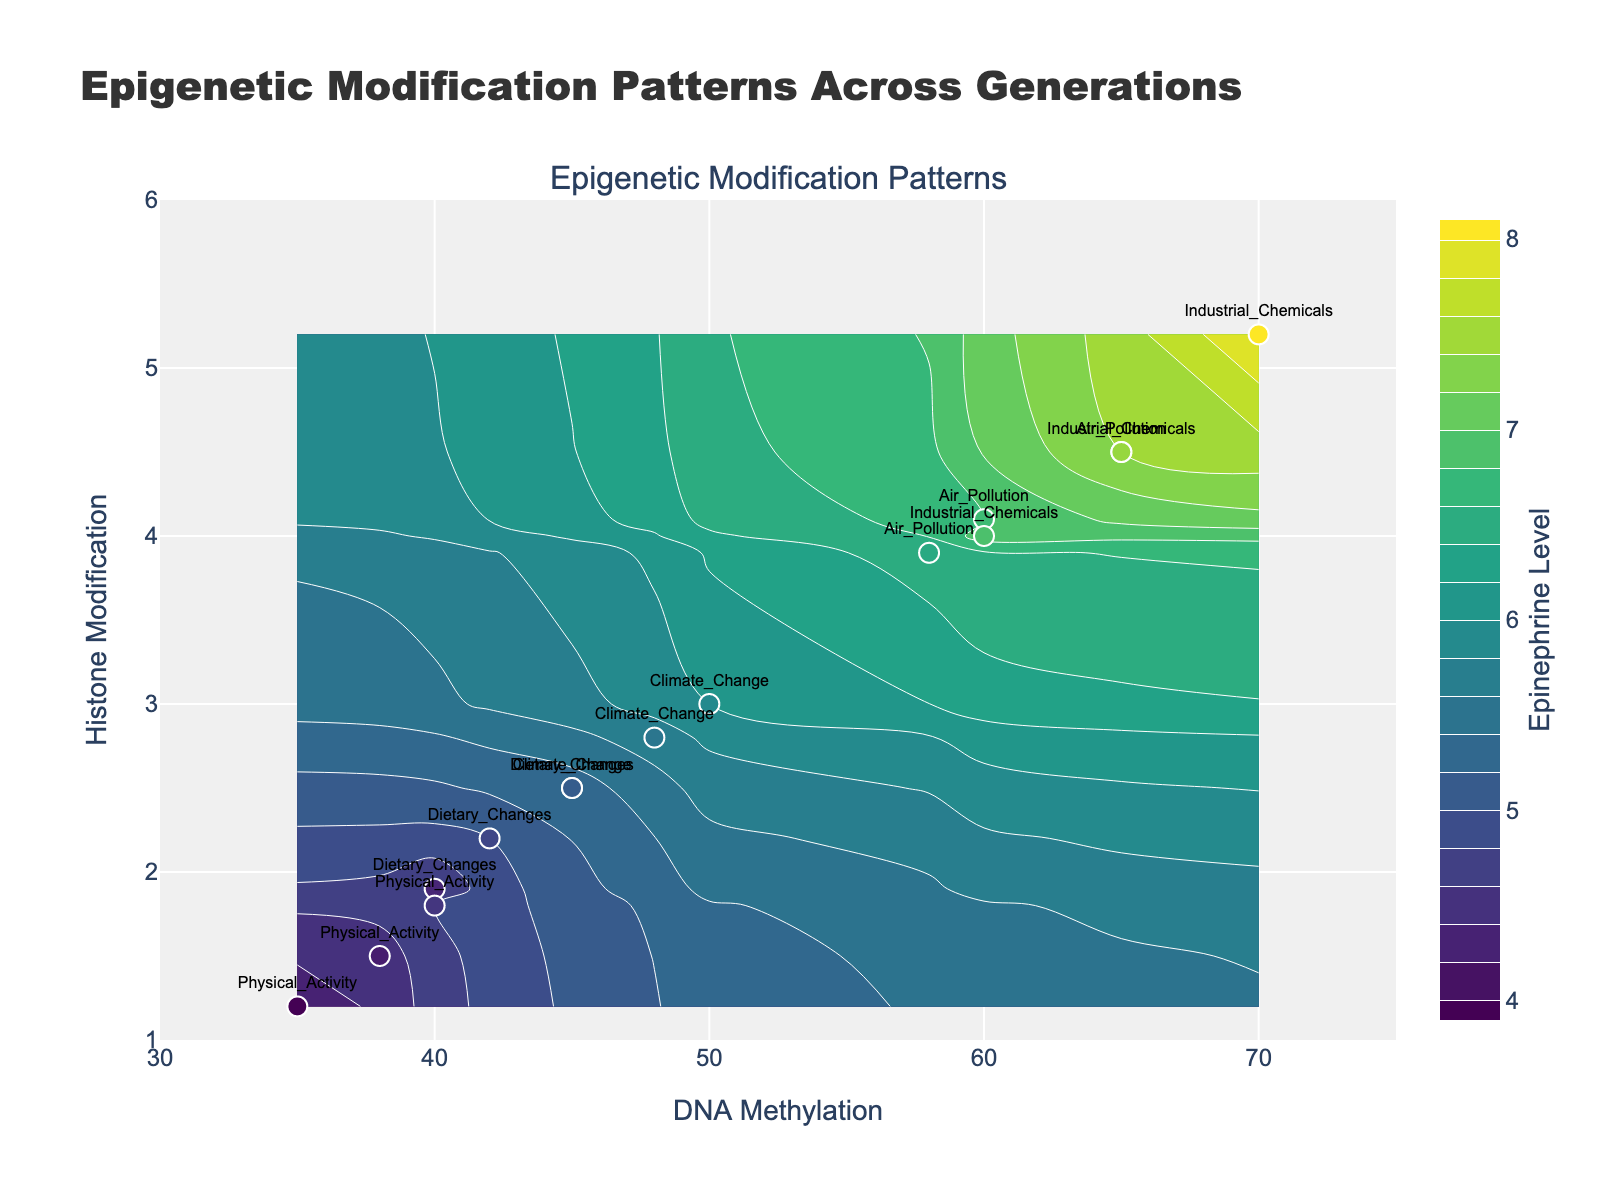What is the title of the figure? The title of the figure is located at the top and reads "Epigenetic Modification Patterns Across Generations".
Answer: Epigenetic Modification Patterns Across Generations What are the ranges of the x-axis and y-axis? The x-axis (DNA Methylation) ranges from 30 to 75, and the y-axis (Histone Modification) ranges from 1 to 6, as indicated by the axis labels and tick marks.
Answer: DNA Methylation: 30-75, Histone Modification: 1-6 How does the epinephrine level vary across different environmental factors? To answer this, observe the color intensities and values on the contour plot associated with different environmental factors labeled on the scatter points. 'Industrial Chemicals' and 'Air Pollution' have higher epinephrine levels (warmer colors), while 'Physical Activity' and 'Dietary Changes' have lower levels (cooler colors).
Answer: Higher with 'Industrial Chemicals' and 'Air Pollution', lower with 'Physical Activity' and 'Dietary Changes' Which environmental factor in Generation 3 has the lowest epinephrine level? By examining the scatter points and their textual labels, we find that 'Physical Activity' in Generation 3 corresponds to the lowest epinephrine level, associated with the lowest color value on the color scale.
Answer: Physical Activity Between Air Pollution and Dietary Changes in Generation 1, which has a higher DNA Methylation level? Looking at the scatter data points for Generation 1, 'Air Pollution' corresponds to a DNA Methylation level of 65, while 'Dietary Changes' corresponds to a DNA Methylation level of 45, making 'Air Pollution' higher.
Answer: Air Pollution What is the range of histone modification levels for Climate Change across generations? The histone modification levels for 'Climate Change' across Generation 1, 2, and 3 are 3.0, 2.8, and 2.5, respectively.
Answer: 2.5 to 3.0 Which generation shows the highest variability in DNA Methylation levels among the different environmental factors? By comparing the DNA Methylation levels of the environmental factors within each generation, Generation 1 shows the highest variability, ranging from 40 (Physical Activity) to 70 (Industrial Chemicals).
Answer: Generation 1 What is the relationship between DNA Methylation and Histone Modification levels for Industrial Chemicals across generations? Observe the scatter points for 'Industrial Chemicals' across generations. DNA Methylation levels decrease from 70 to 60 while Histone Modification levels decrease from 5.2 to 4.0 over the generations. This indicates that as DNA Methylation decreases, Histone Modification also decreases.
Answer: Both decrease Which environmental factor is associated with the highest epinephrine level, and in which generation? The contour plot and scatter point labels show that 'Industrial Chemicals' in Generation 1 has the highest epinephrine level indicated by the highest color intensity.
Answer: Industrial Chemicals, Generation 1 What is the difference in DNA Methylation between Air Pollution in Generation 1 and Generation 3? The DNA Methylation levels for 'Air Pollution' in Generation 1 and Generation 3 are 65 and 58, respectively. The difference is 65 - 58 = 7.
Answer: 7 